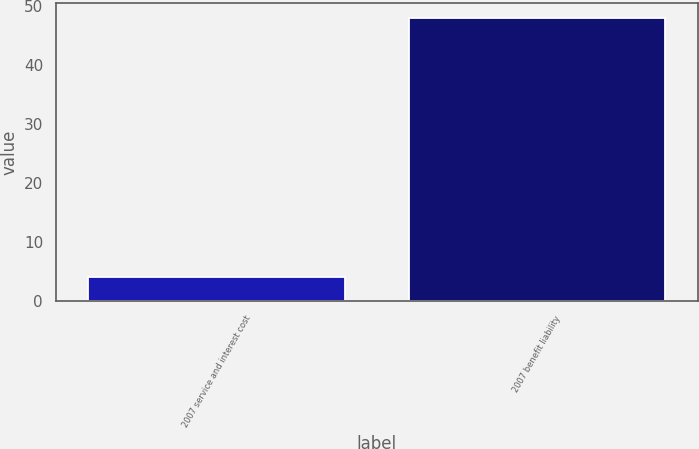<chart> <loc_0><loc_0><loc_500><loc_500><bar_chart><fcel>2007 service and interest cost<fcel>2007 benefit liability<nl><fcel>4<fcel>48<nl></chart> 